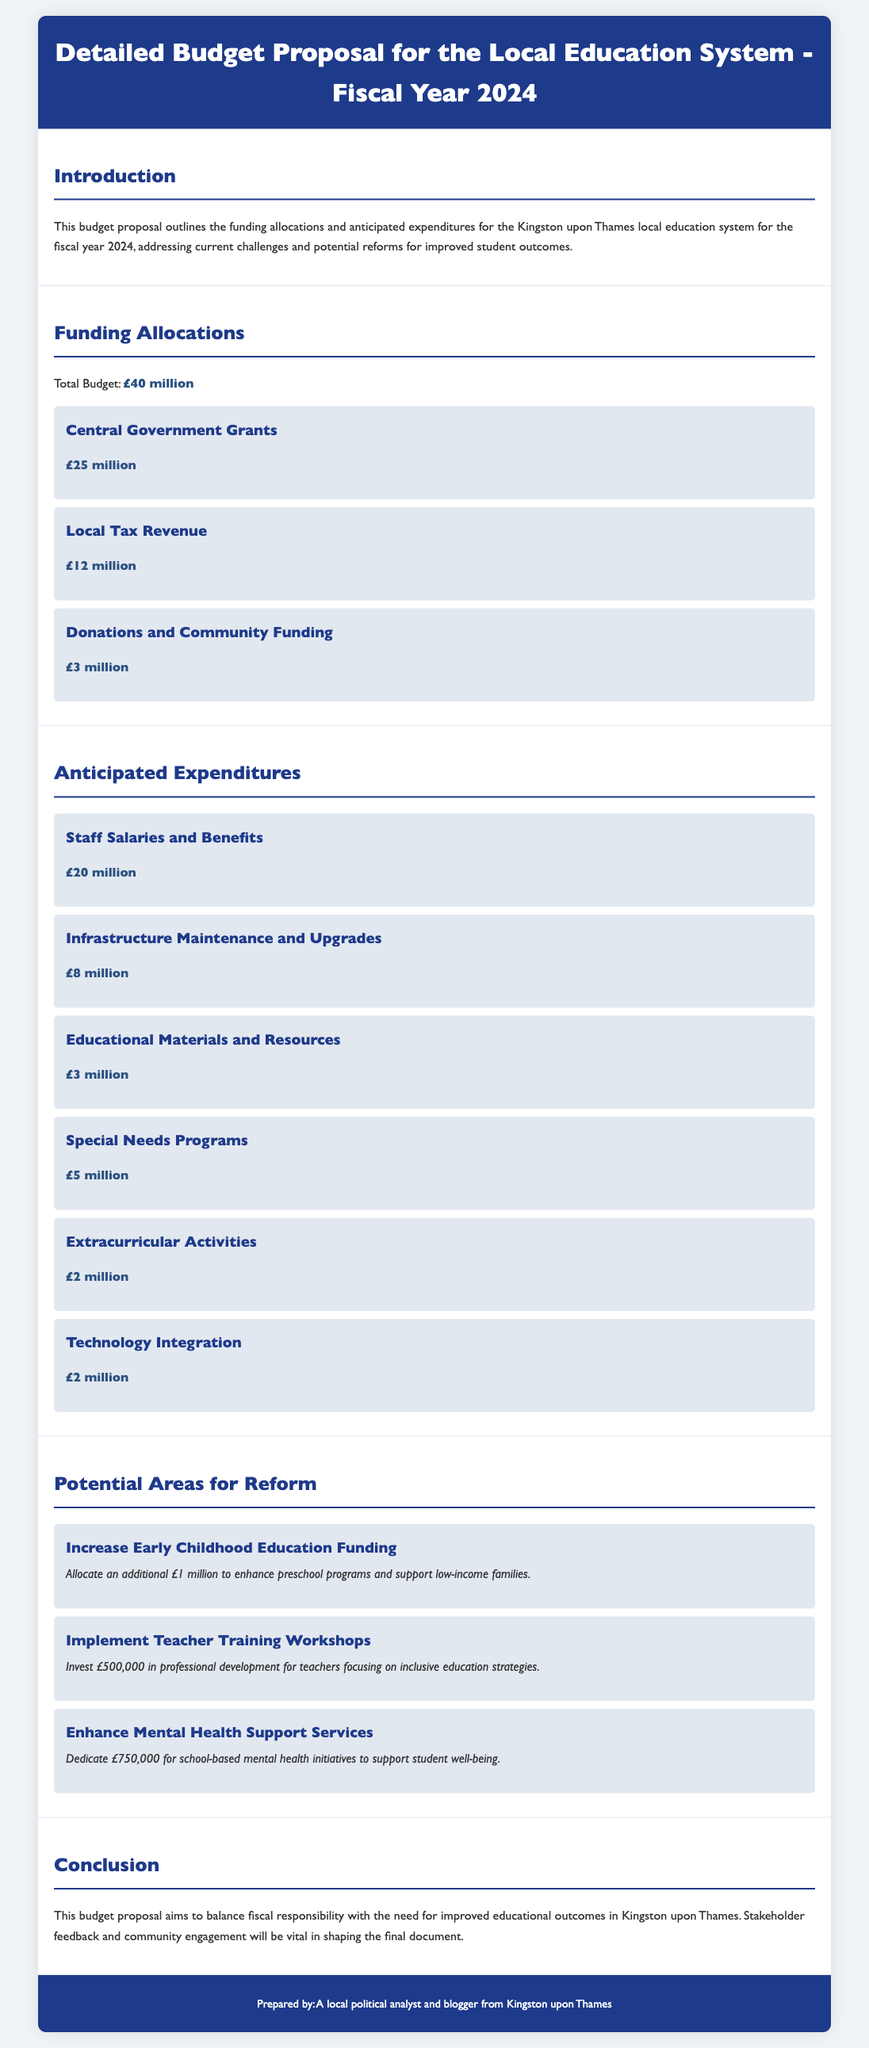What is the total budget for the fiscal year 2024? The total budget is directly stated in the document under Funding Allocations.
Answer: £40 million How much is allocated from Central Government Grants? This amount is specifically mentioned in the Funding Allocations section.
Answer: £25 million What is the expenditure for Staff Salaries and Benefits? The document clearly lists this under Anticipated Expenditures.
Answer: £20 million What is the proposed funding increase for Early Childhood Education? This information is found in the Potential Areas for Reform section and specifies the additional allocation.
Answer: £1 million How much is dedicated to enhance mental health support services? The amount for this initiative is detailed in the Potential Areas for Reform section.
Answer: £750,000 What percentage of the total budget is allocated to Infrastructure Maintenance and Upgrades? Calculating the percentage based on the total budget and the allocated amount gives this information.
Answer: 20% How many areas for reform are proposed in the document? This can be determined by counting the reform items listed under Potential Areas for Reform.
Answer: 3 What is the purpose of the proposed teacher training workshops? The document provides insight into the aim of this expenditure in the description section.
Answer: Inclusive education strategies What is one major anticipated expenditure apart from Staff Salaries and Benefits? The document includes various expenditures, and this one is explicitly listed.
Answer: Infrastructure Maintenance and Upgrades What role do community engagement and stakeholder feedback play in the proposal? The conclusion emphasizes the importance of this aspect in shaping the final document.
Answer: Vital 